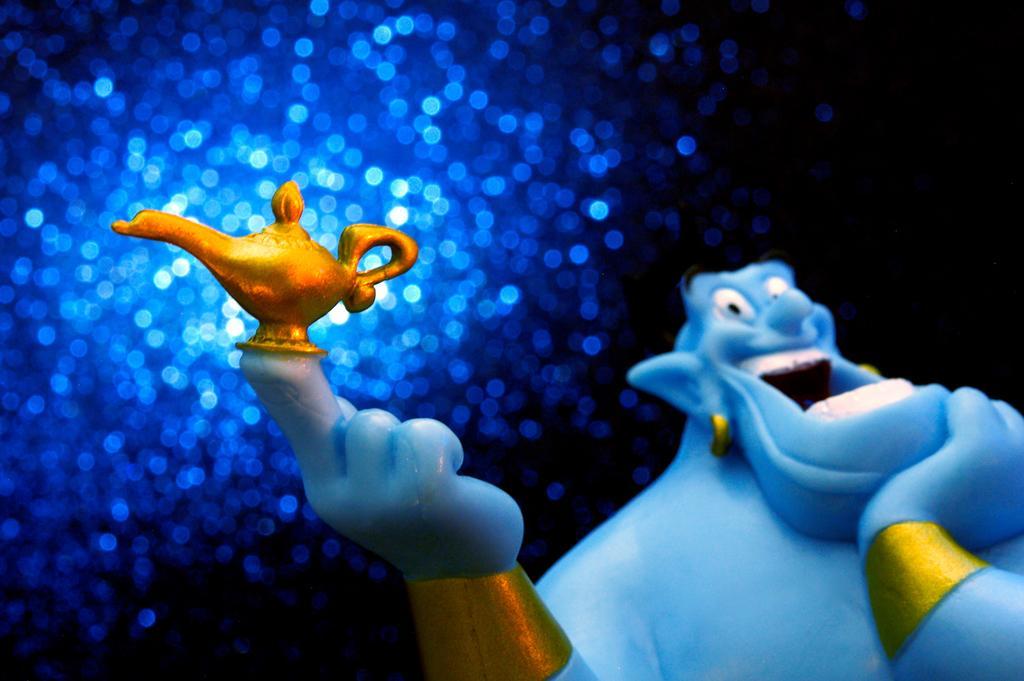Could you give a brief overview of what you see in this image? In this image we can see there is a genie holding the lamp. In the background there are sprinkles of light in sky blue color. 